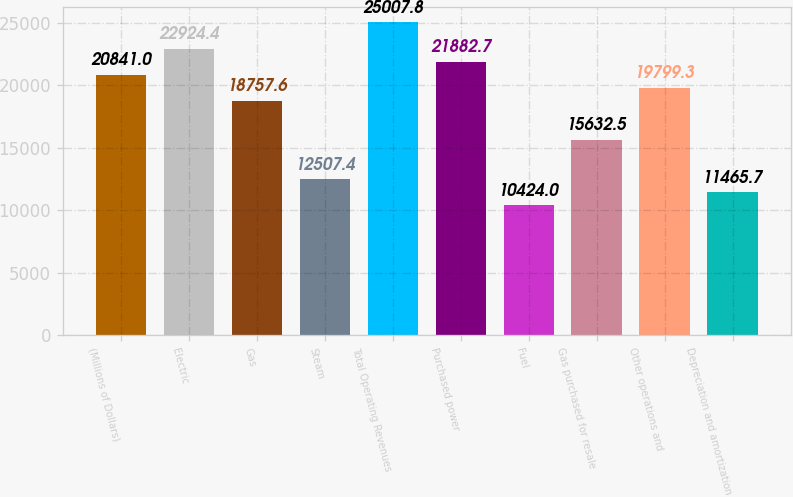<chart> <loc_0><loc_0><loc_500><loc_500><bar_chart><fcel>(Millions of Dollars)<fcel>Electric<fcel>Gas<fcel>Steam<fcel>Total Operating Revenues<fcel>Purchased power<fcel>Fuel<fcel>Gas purchased for resale<fcel>Other operations and<fcel>Depreciation and amortization<nl><fcel>20841<fcel>22924.4<fcel>18757.6<fcel>12507.4<fcel>25007.8<fcel>21882.7<fcel>10424<fcel>15632.5<fcel>19799.3<fcel>11465.7<nl></chart> 